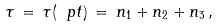<formula> <loc_0><loc_0><loc_500><loc_500>\tau \, = \, \tau ( \ p t ) \, = \, n _ { 1 } + n _ { 2 } + n _ { 3 } \, ,</formula> 